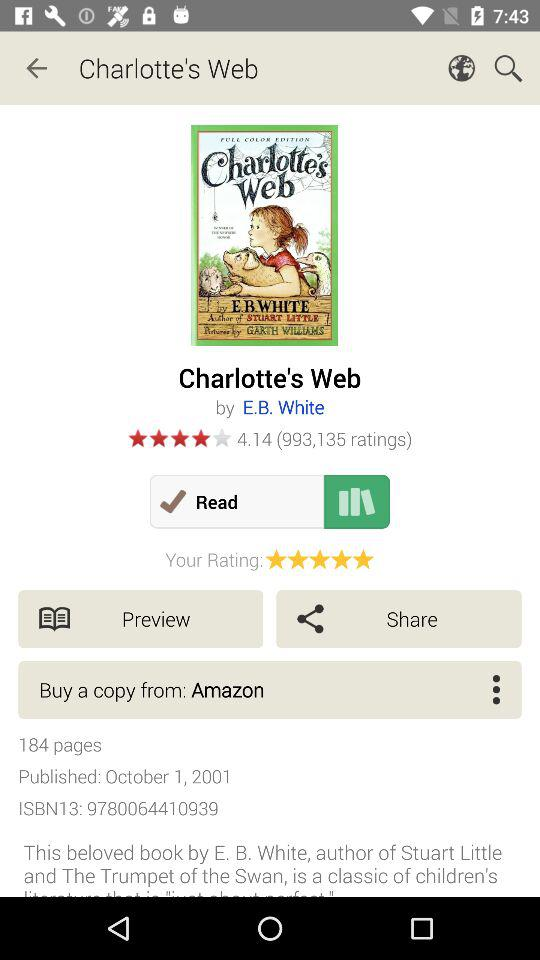What is the publication date of the book? The publication date of the book is October 1, 2001. 